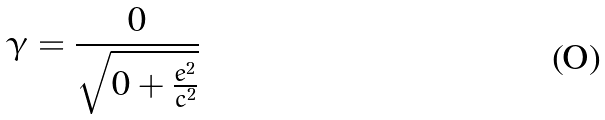<formula> <loc_0><loc_0><loc_500><loc_500>\gamma = \frac { 0 } { \sqrt { 0 + \frac { e ^ { 2 } } { c ^ { 2 } } } }</formula> 